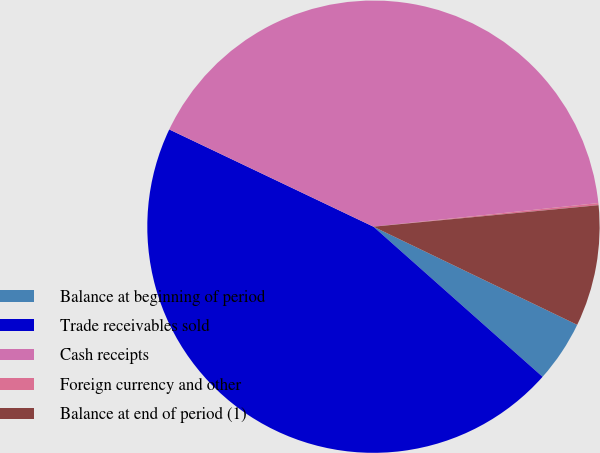<chart> <loc_0><loc_0><loc_500><loc_500><pie_chart><fcel>Balance at beginning of period<fcel>Trade receivables sold<fcel>Cash receipts<fcel>Foreign currency and other<fcel>Balance at end of period (1)<nl><fcel>4.41%<fcel>45.52%<fcel>41.26%<fcel>0.15%<fcel>8.66%<nl></chart> 